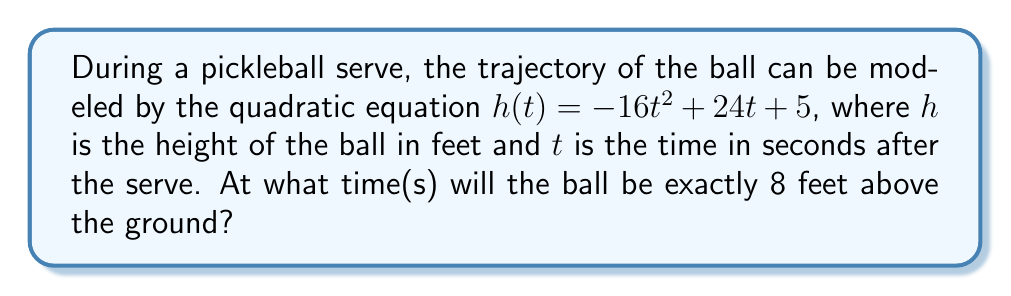Give your solution to this math problem. To solve this problem, we need to find the value(s) of $t$ where $h(t) = 8$. Let's approach this step-by-step:

1) We start with the equation: $h(t) = -16t^2 + 24t + 5$

2) We want to find when $h(t) = 8$, so we set up the equation:
   $8 = -16t^2 + 24t + 5$

3) Subtract 8 from both sides to get the equation in standard form:
   $0 = -16t^2 + 24t - 3$

4) This is a quadratic equation in the form $at^2 + bt + c = 0$, where:
   $a = -16$, $b = 24$, and $c = -3$

5) We can solve this using the quadratic formula: $t = \frac{-b \pm \sqrt{b^2 - 4ac}}{2a}$

6) Substituting our values:
   $t = \frac{-24 \pm \sqrt{24^2 - 4(-16)(-3)}}{2(-16)}$

7) Simplify under the square root:
   $t = \frac{-24 \pm \sqrt{576 - 192}}{-32} = \frac{-24 \pm \sqrt{384}}{-32}$

8) Simplify further:
   $t = \frac{-24 \pm 8\sqrt{6}}{-32}$

9) Separate into two solutions:
   $t = \frac{-24 + 8\sqrt{6}}{-32}$ or $t = \frac{-24 - 8\sqrt{6}}{-32}$

10) Simplify:
    $t = \frac{3 - \sqrt{6}}{4}$ or $t = \frac{3 + \sqrt{6}}{4}$

Therefore, the ball will be exactly 8 feet above the ground at two times.
Answer: The ball will be 8 feet above the ground at $t = \frac{3 - \sqrt{6}}{4}$ seconds and $t = \frac{3 + \sqrt{6}}{4}$ seconds after the serve. 